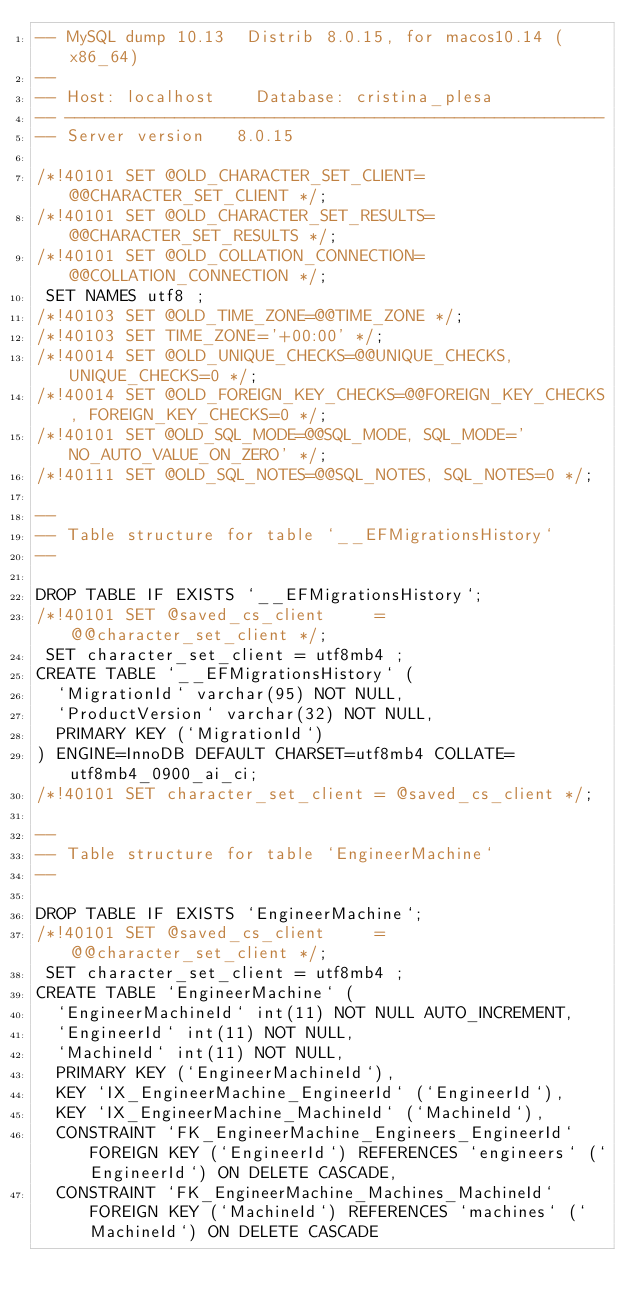Convert code to text. <code><loc_0><loc_0><loc_500><loc_500><_SQL_>-- MySQL dump 10.13  Distrib 8.0.15, for macos10.14 (x86_64)
--
-- Host: localhost    Database: cristina_plesa
-- ------------------------------------------------------
-- Server version	8.0.15

/*!40101 SET @OLD_CHARACTER_SET_CLIENT=@@CHARACTER_SET_CLIENT */;
/*!40101 SET @OLD_CHARACTER_SET_RESULTS=@@CHARACTER_SET_RESULTS */;
/*!40101 SET @OLD_COLLATION_CONNECTION=@@COLLATION_CONNECTION */;
 SET NAMES utf8 ;
/*!40103 SET @OLD_TIME_ZONE=@@TIME_ZONE */;
/*!40103 SET TIME_ZONE='+00:00' */;
/*!40014 SET @OLD_UNIQUE_CHECKS=@@UNIQUE_CHECKS, UNIQUE_CHECKS=0 */;
/*!40014 SET @OLD_FOREIGN_KEY_CHECKS=@@FOREIGN_KEY_CHECKS, FOREIGN_KEY_CHECKS=0 */;
/*!40101 SET @OLD_SQL_MODE=@@SQL_MODE, SQL_MODE='NO_AUTO_VALUE_ON_ZERO' */;
/*!40111 SET @OLD_SQL_NOTES=@@SQL_NOTES, SQL_NOTES=0 */;

--
-- Table structure for table `__EFMigrationsHistory`
--

DROP TABLE IF EXISTS `__EFMigrationsHistory`;
/*!40101 SET @saved_cs_client     = @@character_set_client */;
 SET character_set_client = utf8mb4 ;
CREATE TABLE `__EFMigrationsHistory` (
  `MigrationId` varchar(95) NOT NULL,
  `ProductVersion` varchar(32) NOT NULL,
  PRIMARY KEY (`MigrationId`)
) ENGINE=InnoDB DEFAULT CHARSET=utf8mb4 COLLATE=utf8mb4_0900_ai_ci;
/*!40101 SET character_set_client = @saved_cs_client */;

--
-- Table structure for table `EngineerMachine`
--

DROP TABLE IF EXISTS `EngineerMachine`;
/*!40101 SET @saved_cs_client     = @@character_set_client */;
 SET character_set_client = utf8mb4 ;
CREATE TABLE `EngineerMachine` (
  `EngineerMachineId` int(11) NOT NULL AUTO_INCREMENT,
  `EngineerId` int(11) NOT NULL,
  `MachineId` int(11) NOT NULL,
  PRIMARY KEY (`EngineerMachineId`),
  KEY `IX_EngineerMachine_EngineerId` (`EngineerId`),
  KEY `IX_EngineerMachine_MachineId` (`MachineId`),
  CONSTRAINT `FK_EngineerMachine_Engineers_EngineerId` FOREIGN KEY (`EngineerId`) REFERENCES `engineers` (`EngineerId`) ON DELETE CASCADE,
  CONSTRAINT `FK_EngineerMachine_Machines_MachineId` FOREIGN KEY (`MachineId`) REFERENCES `machines` (`MachineId`) ON DELETE CASCADE</code> 